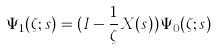Convert formula to latex. <formula><loc_0><loc_0><loc_500><loc_500>\Psi _ { 1 } ( \zeta ; s ) = ( I - \frac { 1 } { \zeta } X ( s ) ) \Psi _ { 0 } ( \zeta ; s )</formula> 